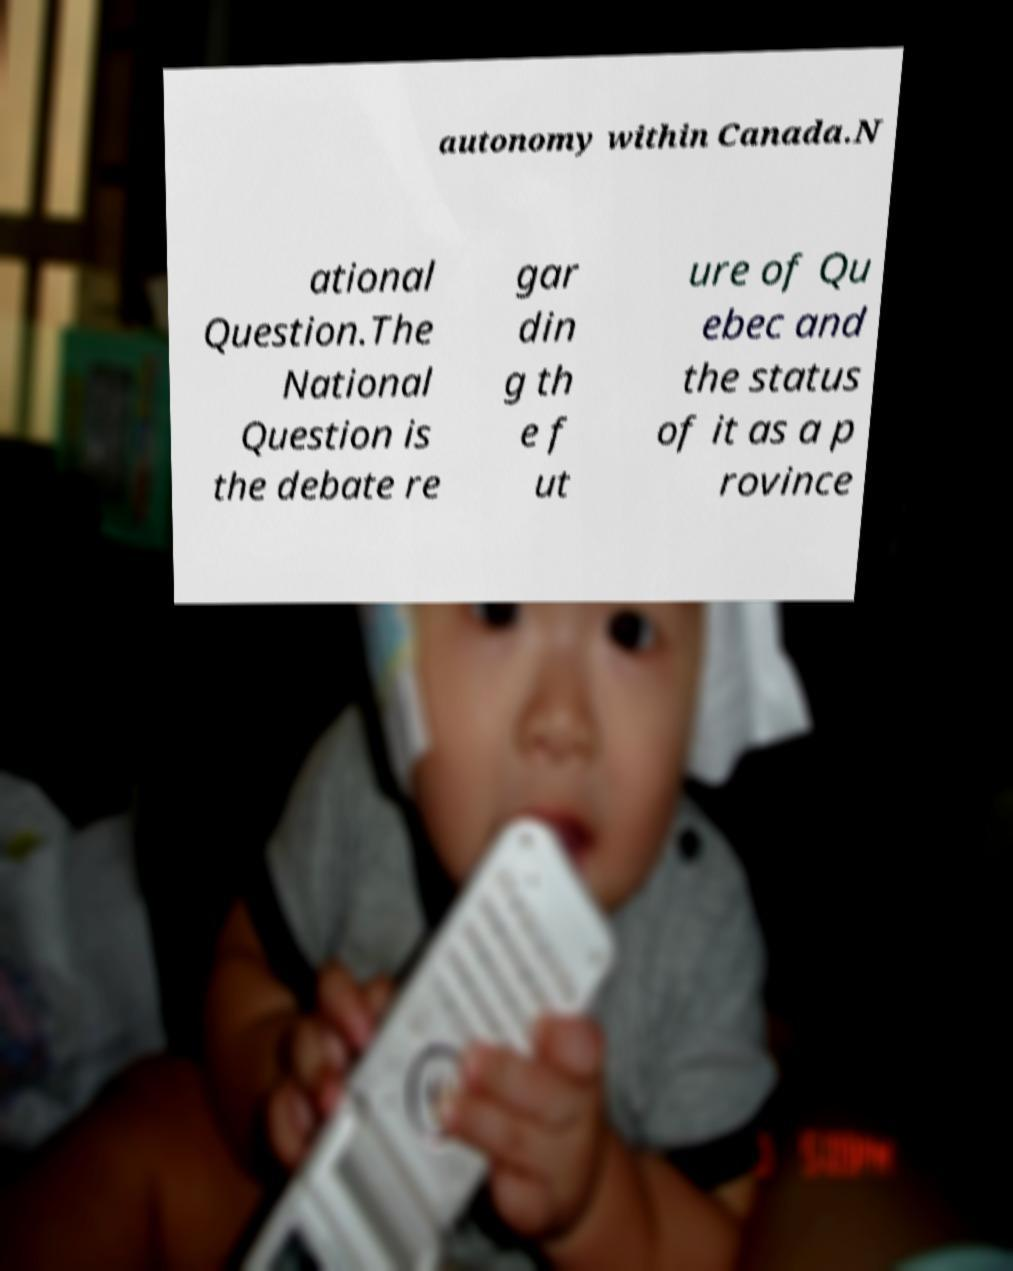I need the written content from this picture converted into text. Can you do that? autonomy within Canada.N ational Question.The National Question is the debate re gar din g th e f ut ure of Qu ebec and the status of it as a p rovince 